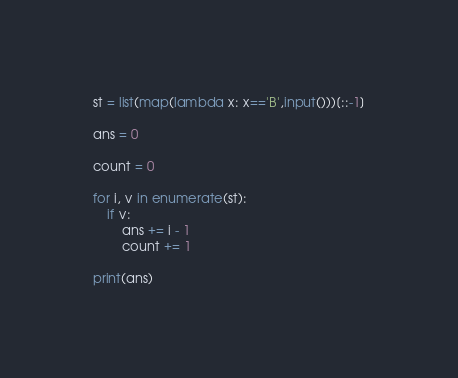Convert code to text. <code><loc_0><loc_0><loc_500><loc_500><_Python_>st = list(map(lambda x: x=='B',input()))[::-1]

ans = 0

count = 0

for i, v in enumerate(st):
    if v:
        ans += i - 1
        count += 1

print(ans)</code> 